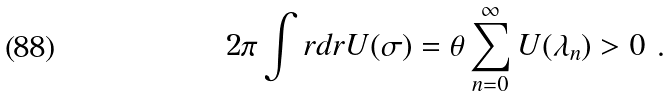Convert formula to latex. <formula><loc_0><loc_0><loc_500><loc_500>2 \pi \int r d r U ( \sigma ) = \theta \sum _ { n = 0 } ^ { \infty } U ( \lambda _ { n } ) > 0 \ .</formula> 